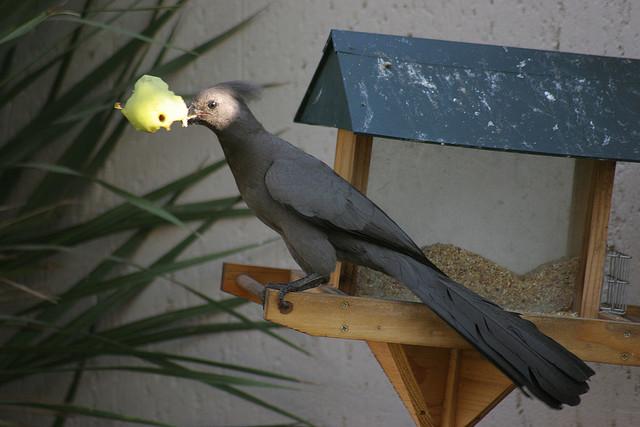Is the bird eating something?
Short answer required. Yes. What kind of bird is this?
Write a very short answer. Parrot. What is the bird standing on?
Short answer required. Birdhouse. What is the bird eating?
Write a very short answer. Flower. Is the bird sitting on a perch?
Answer briefly. Yes. Can you see any plants?
Write a very short answer. Yes. What is the bird sitting on?
Write a very short answer. Birdhouse. What is the bird looking at?
Give a very brief answer. Flower. How many birds are there?
Answer briefly. 1. What is inside the little house?
Write a very short answer. Bird seed. What is a word to describe this type of plant?
Be succinct. Green. What kind of bird is on the feeder?
Quick response, please. Sparrow. 